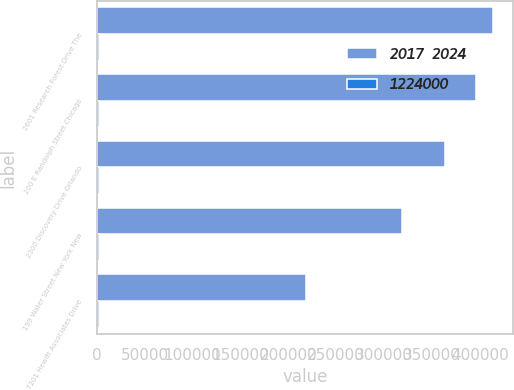Convert chart to OTSL. <chart><loc_0><loc_0><loc_500><loc_500><stacked_bar_chart><ecel><fcel>2601 Research Forest Drive The<fcel>200 E Randolph Street Chicago<fcel>2300 Discovery Drive Orlando<fcel>199 Water Street New York New<fcel>7201 Hewitt Associates Drive<nl><fcel>2017  2024<fcel>414000<fcel>396000<fcel>364000<fcel>319000<fcel>218000<nl><fcel>1224000<fcel>2020<fcel>2028<fcel>2020<fcel>2018<fcel>2015<nl></chart> 